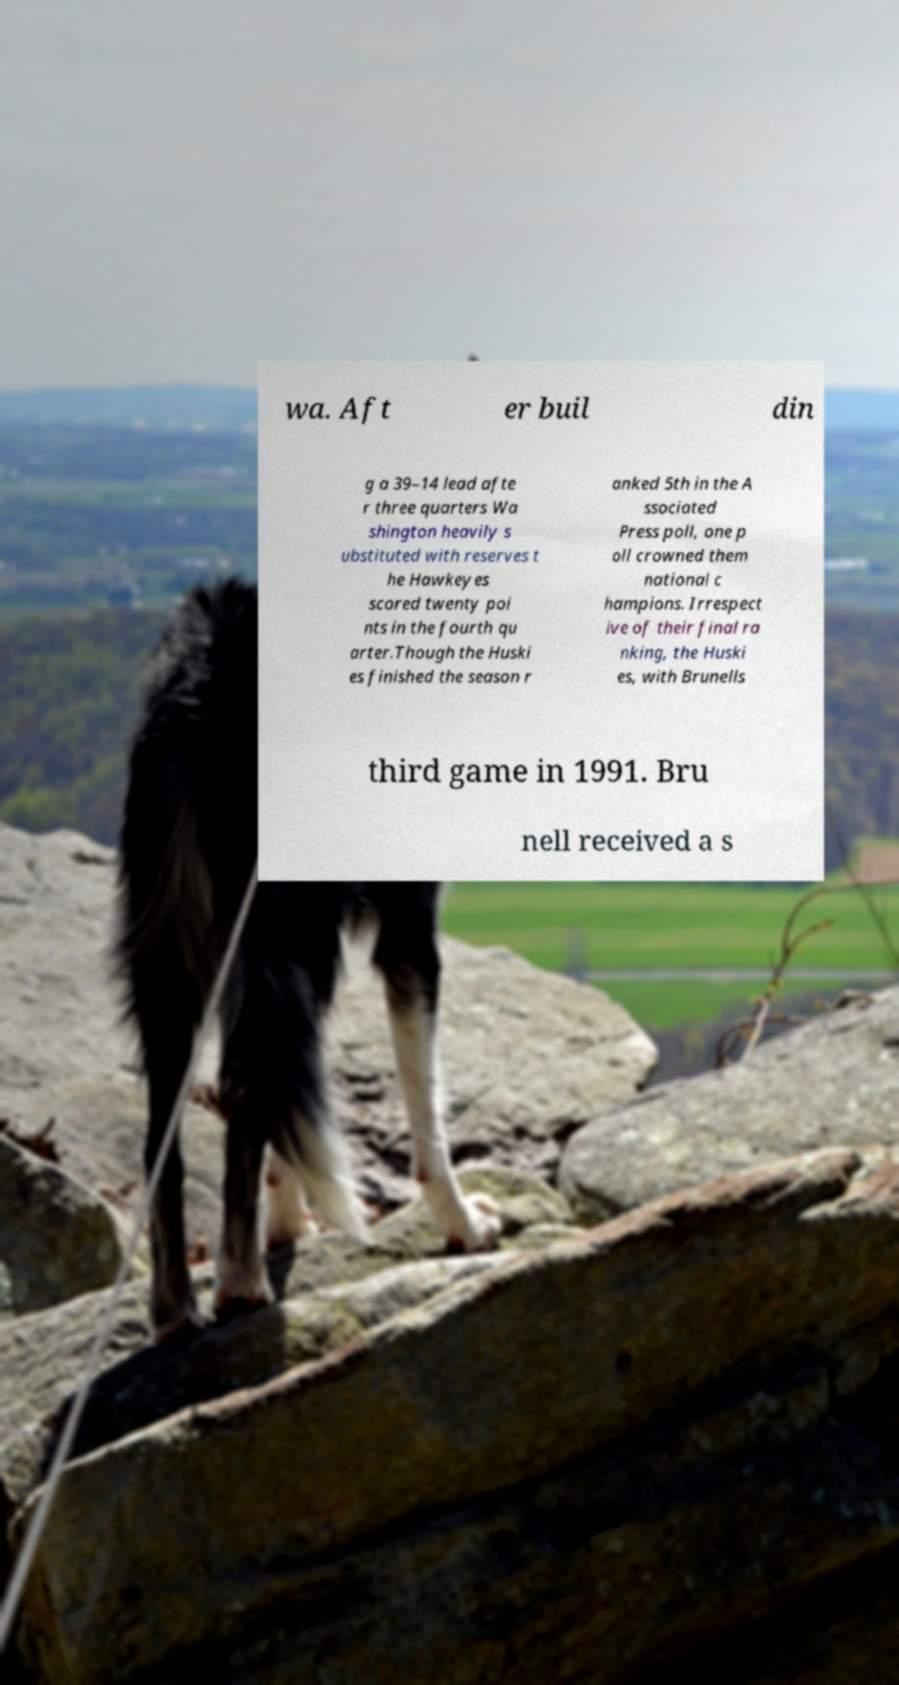For documentation purposes, I need the text within this image transcribed. Could you provide that? wa. Aft er buil din g a 39–14 lead afte r three quarters Wa shington heavily s ubstituted with reserves t he Hawkeyes scored twenty poi nts in the fourth qu arter.Though the Huski es finished the season r anked 5th in the A ssociated Press poll, one p oll crowned them national c hampions. Irrespect ive of their final ra nking, the Huski es, with Brunells third game in 1991. Bru nell received a s 